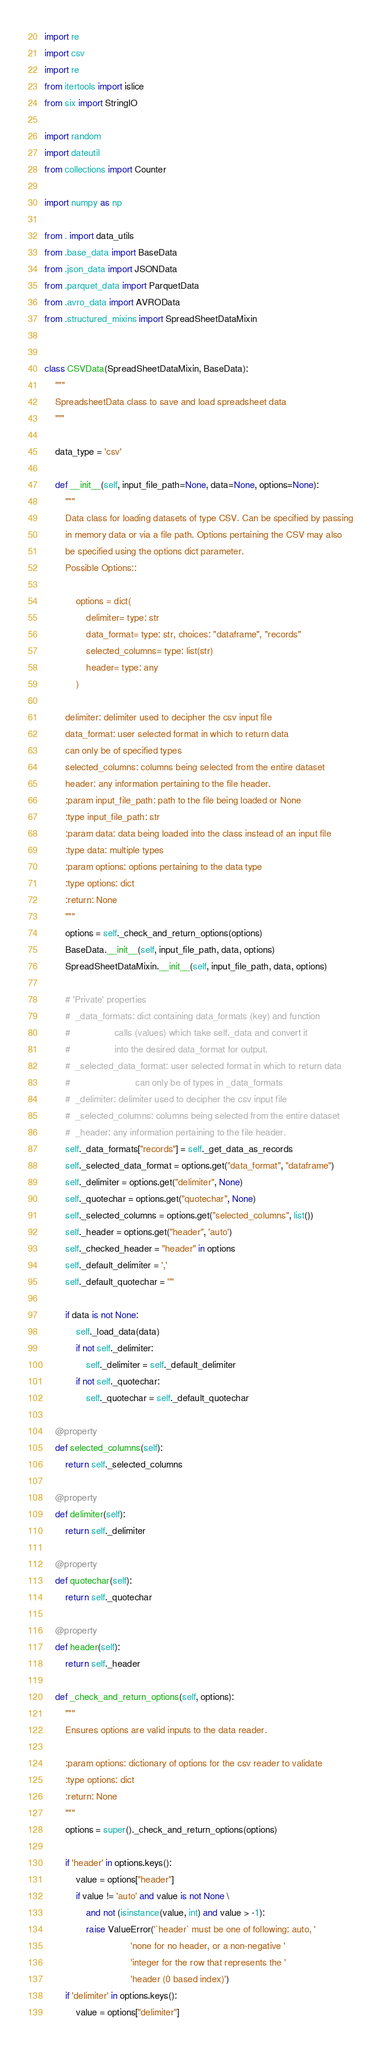<code> <loc_0><loc_0><loc_500><loc_500><_Python_>import re
import csv
import re
from itertools import islice
from six import StringIO

import random
import dateutil
from collections import Counter

import numpy as np

from . import data_utils
from .base_data import BaseData
from .json_data import JSONData
from .parquet_data import ParquetData
from .avro_data import AVROData
from .structured_mixins import SpreadSheetDataMixin


class CSVData(SpreadSheetDataMixin, BaseData):
    """
    SpreadsheetData class to save and load spreadsheet data
    """

    data_type = 'csv'

    def __init__(self, input_file_path=None, data=None, options=None):
        """
        Data class for loading datasets of type CSV. Can be specified by passing
        in memory data or via a file path. Options pertaining the CSV may also
        be specified using the options dict parameter.
        Possible Options::

            options = dict(
                delimiter= type: str
                data_format= type: str, choices: "dataframe", "records"
                selected_columns= type: list(str)
                header= type: any
            )

        delimiter: delimiter used to decipher the csv input file
        data_format: user selected format in which to return data
        can only be of specified types
        selected_columns: columns being selected from the entire dataset
        header: any information pertaining to the file header.
        :param input_file_path: path to the file being loaded or None
        :type input_file_path: str
        :param data: data being loaded into the class instead of an input file
        :type data: multiple types
        :param options: options pertaining to the data type
        :type options: dict
        :return: None
        """
        options = self._check_and_return_options(options)
        BaseData.__init__(self, input_file_path, data, options)
        SpreadSheetDataMixin.__init__(self, input_file_path, data, options)

        # 'Private' properties
        #  _data_formats: dict containing data_formats (key) and function
        #                 calls (values) which take self._data and convert it
        #                 into the desired data_format for output.
        #  _selected_data_format: user selected format in which to return data
        #                         can only be of types in _data_formats
        #  _delimiter: delimiter used to decipher the csv input file
        #  _selected_columns: columns being selected from the entire dataset
        #  _header: any information pertaining to the file header.
        self._data_formats["records"] = self._get_data_as_records
        self._selected_data_format = options.get("data_format", "dataframe")
        self._delimiter = options.get("delimiter", None)
        self._quotechar = options.get("quotechar", None)
        self._selected_columns = options.get("selected_columns", list())
        self._header = options.get("header", 'auto')
        self._checked_header = "header" in options
        self._default_delimiter = ','
        self._default_quotechar = '"'

        if data is not None:
            self._load_data(data)
            if not self._delimiter:
                self._delimiter = self._default_delimiter
            if not self._quotechar:
                self._quotechar = self._default_quotechar

    @property
    def selected_columns(self):
        return self._selected_columns

    @property
    def delimiter(self):
        return self._delimiter

    @property
    def quotechar(self):
        return self._quotechar

    @property
    def header(self):
        return self._header

    def _check_and_return_options(self, options):
        """
        Ensures options are valid inputs to the data reader.

        :param options: dictionary of options for the csv reader to validate
        :type options: dict
        :return: None
        """
        options = super()._check_and_return_options(options)
        
        if 'header' in options.keys():
            value = options["header"]
            if value != 'auto' and value is not None \
                and not (isinstance(value, int) and value > -1):
                raise ValueError('`header` must be one of following: auto, '
                                 'none for no header, or a non-negative '
                                 'integer for the row that represents the '
                                 'header (0 based index)')
        if 'delimiter' in options.keys():
            value = options["delimiter"]</code> 